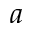Convert formula to latex. <formula><loc_0><loc_0><loc_500><loc_500>a</formula> 